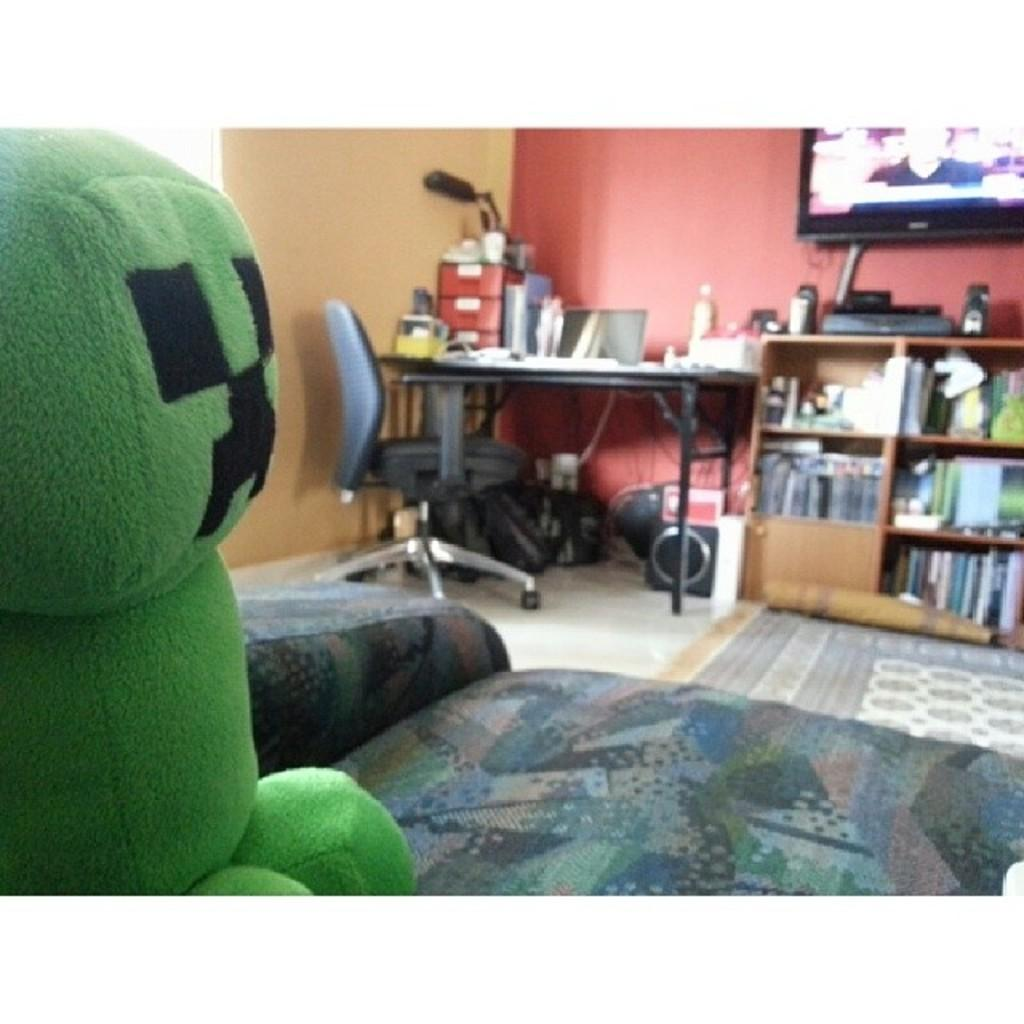What type of space is depicted in the image? There is a room in the image. What furniture is present in the room? There is a sofa, a table, and a chair in the room. What can be found on the table? There are items on the table. What is mounted on the wall in the room? There is a television mounted on the wall. What is stored on the racks in the room? There are racks with books in the room. What type of toy is present in the room? There is a toy in the room. What type of hospital equipment can be seen in the image? There is no hospital equipment present in the image; it depicts a room with furniture and other items. How many passengers are visible in the image? There are no passengers present in the image; it depicts a room with furniture and other items. 